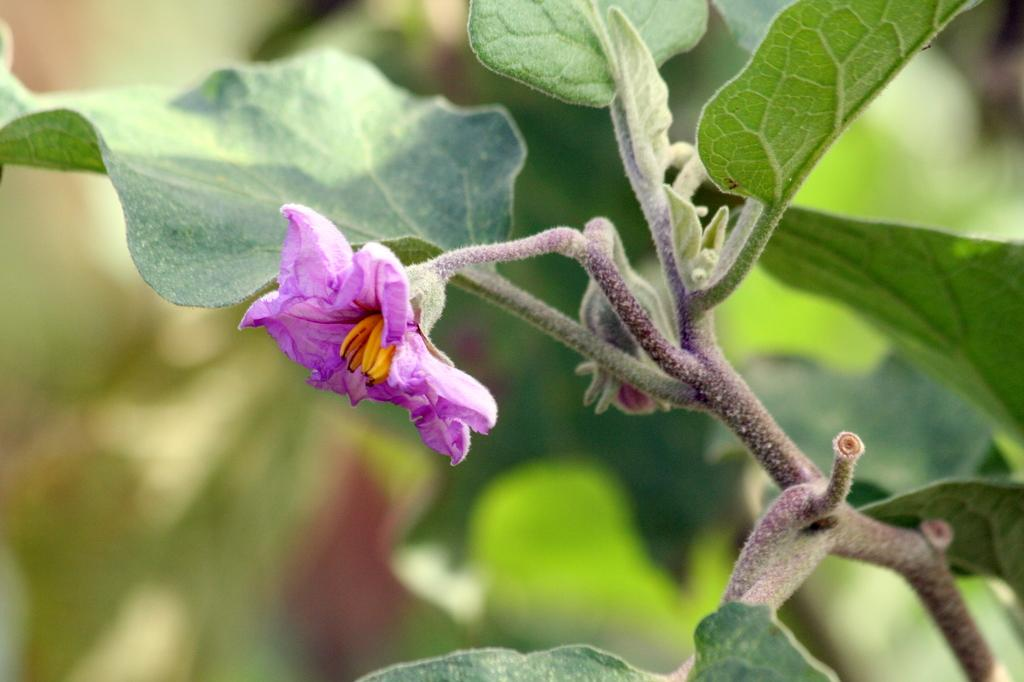Where was the image taken? The image was taken outdoors. What can be seen in the background of the image? There are plants in the background of the image. Can you describe the plant on the right side of the image? The plant on the right side of the image has green leaves and a purple flower. What type of marble is visible on the ground in the image? There is no marble visible on the ground in the image; it features plants and a plant with green leaves and a purple flower. 